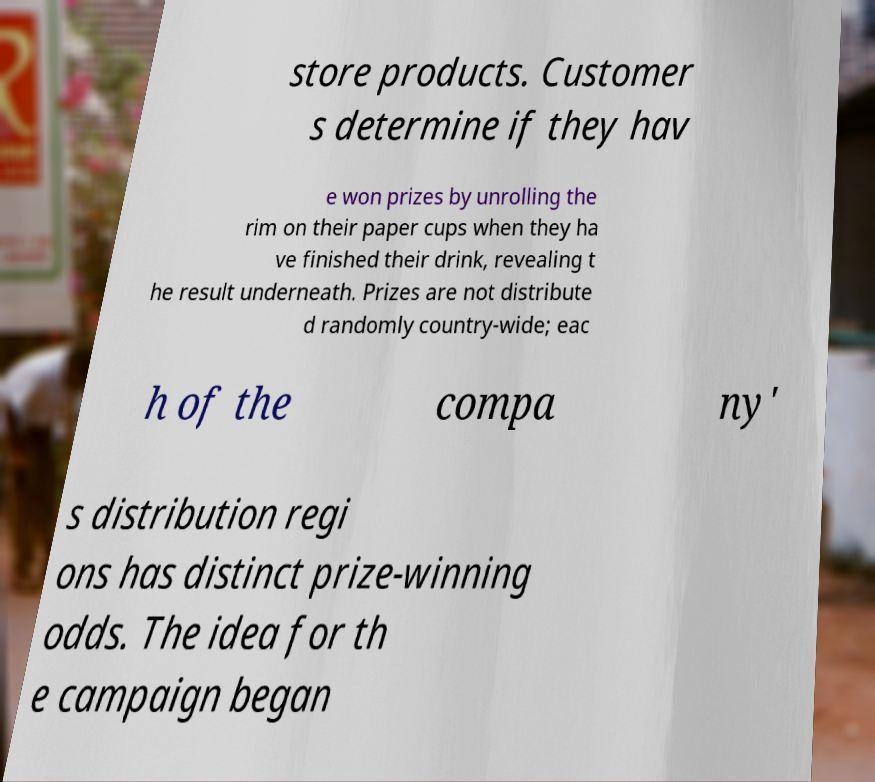For documentation purposes, I need the text within this image transcribed. Could you provide that? store products. Customer s determine if they hav e won prizes by unrolling the rim on their paper cups when they ha ve finished their drink, revealing t he result underneath. Prizes are not distribute d randomly country-wide; eac h of the compa ny' s distribution regi ons has distinct prize-winning odds. The idea for th e campaign began 